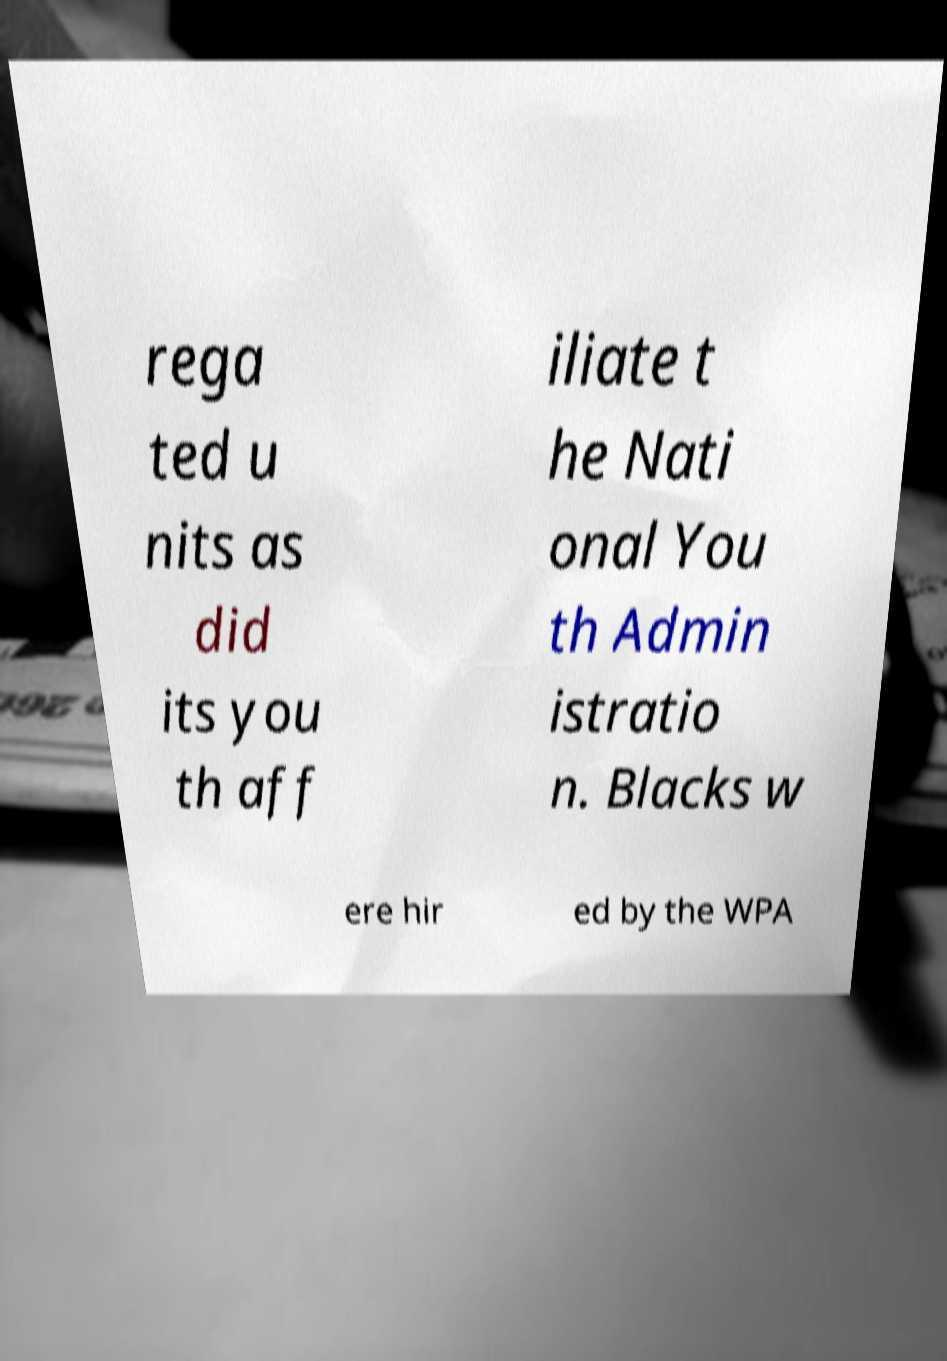Can you accurately transcribe the text from the provided image for me? rega ted u nits as did its you th aff iliate t he Nati onal You th Admin istratio n. Blacks w ere hir ed by the WPA 